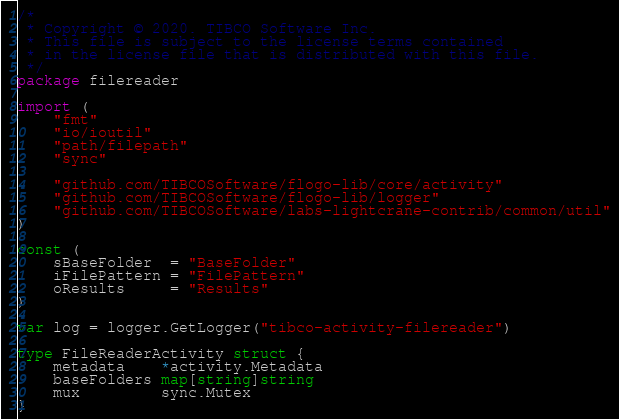Convert code to text. <code><loc_0><loc_0><loc_500><loc_500><_Go_>/*
 * Copyright © 2020. TIBCO Software Inc.
 * This file is subject to the license terms contained
 * in the license file that is distributed with this file.
 */
package filereader

import (
	"fmt"
	"io/ioutil"
	"path/filepath"
	"sync"

	"github.com/TIBCOSoftware/flogo-lib/core/activity"
	"github.com/TIBCOSoftware/flogo-lib/logger"
	"github.com/TIBCOSoftware/labs-lightcrane-contrib/common/util"
)

const (
	sBaseFolder  = "BaseFolder"
	iFilePattern = "FilePattern"
	oResults     = "Results"
)

var log = logger.GetLogger("tibco-activity-filereader")

type FileReaderActivity struct {
	metadata    *activity.Metadata
	baseFolders map[string]string
	mux         sync.Mutex
}
</code> 